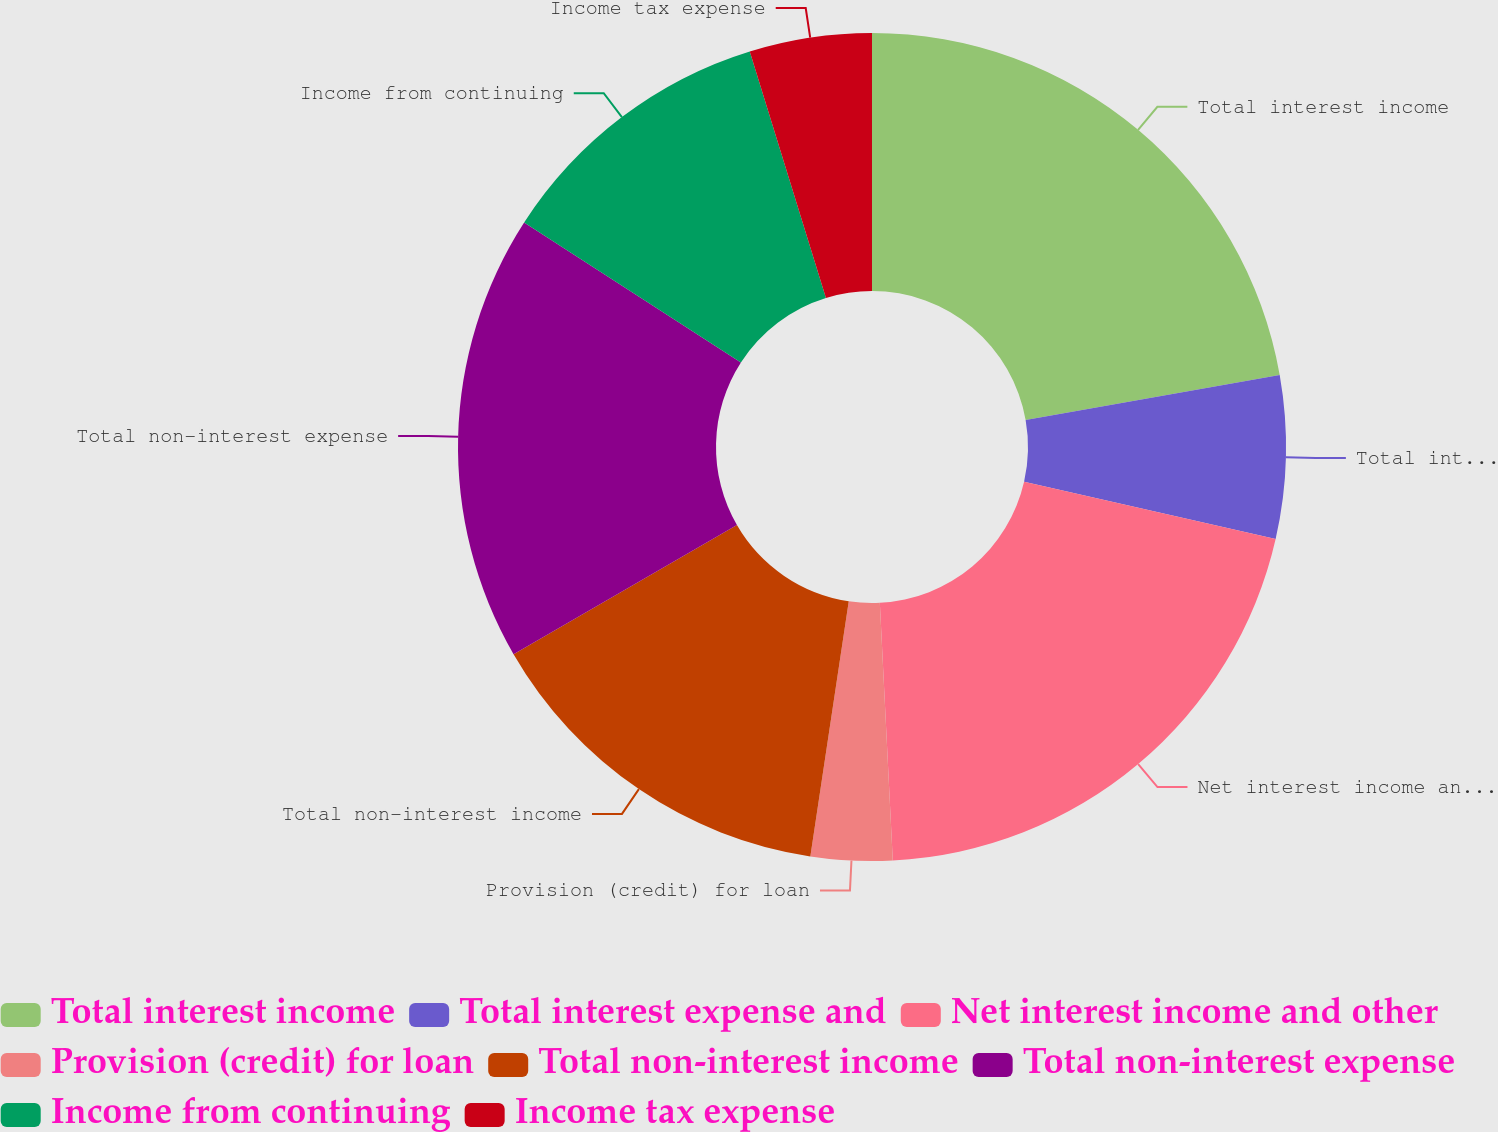<chart> <loc_0><loc_0><loc_500><loc_500><pie_chart><fcel>Total interest income<fcel>Total interest expense and<fcel>Net interest income and other<fcel>Provision (credit) for loan<fcel>Total non-interest income<fcel>Total non-interest expense<fcel>Income from continuing<fcel>Income tax expense<nl><fcel>22.22%<fcel>6.35%<fcel>20.63%<fcel>3.18%<fcel>14.28%<fcel>17.46%<fcel>11.11%<fcel>4.77%<nl></chart> 